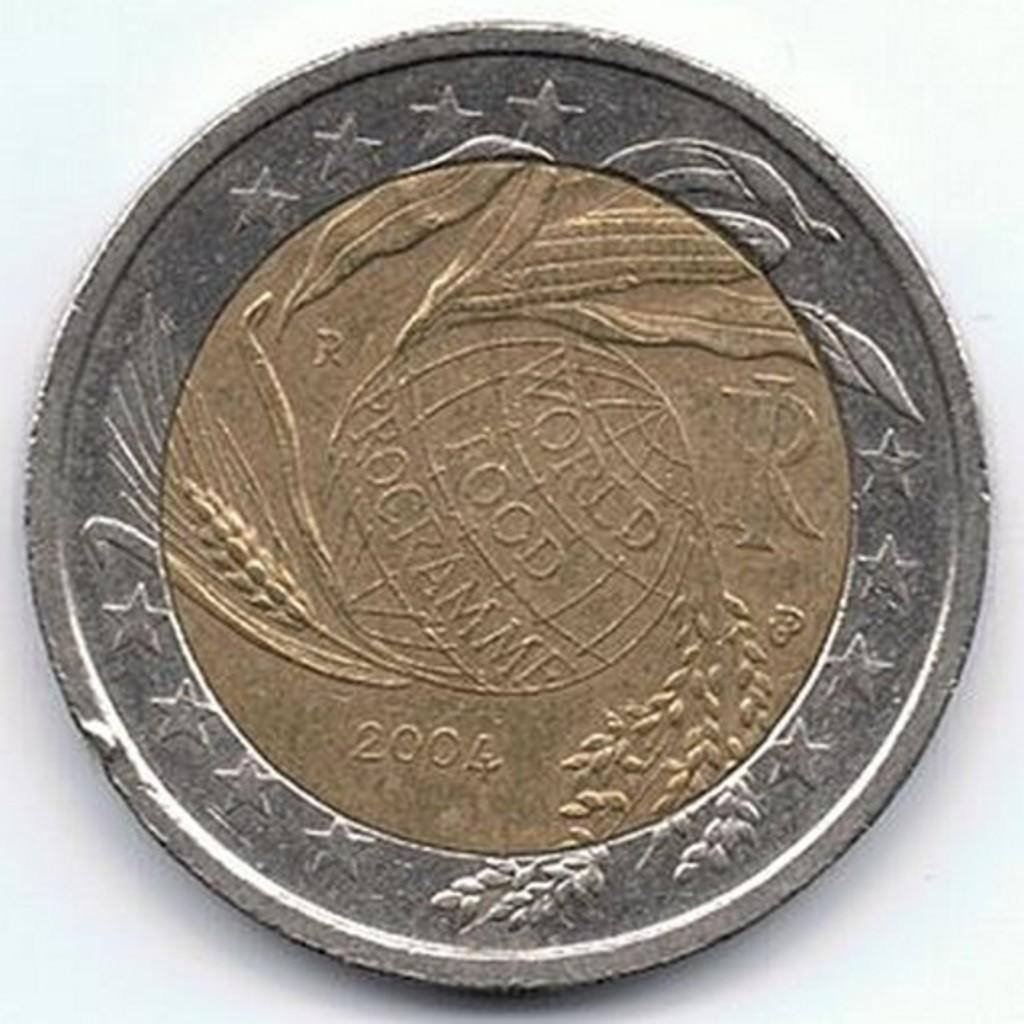<image>
Provide a brief description of the given image. A gold and silver coin has the year 2004 on it. 